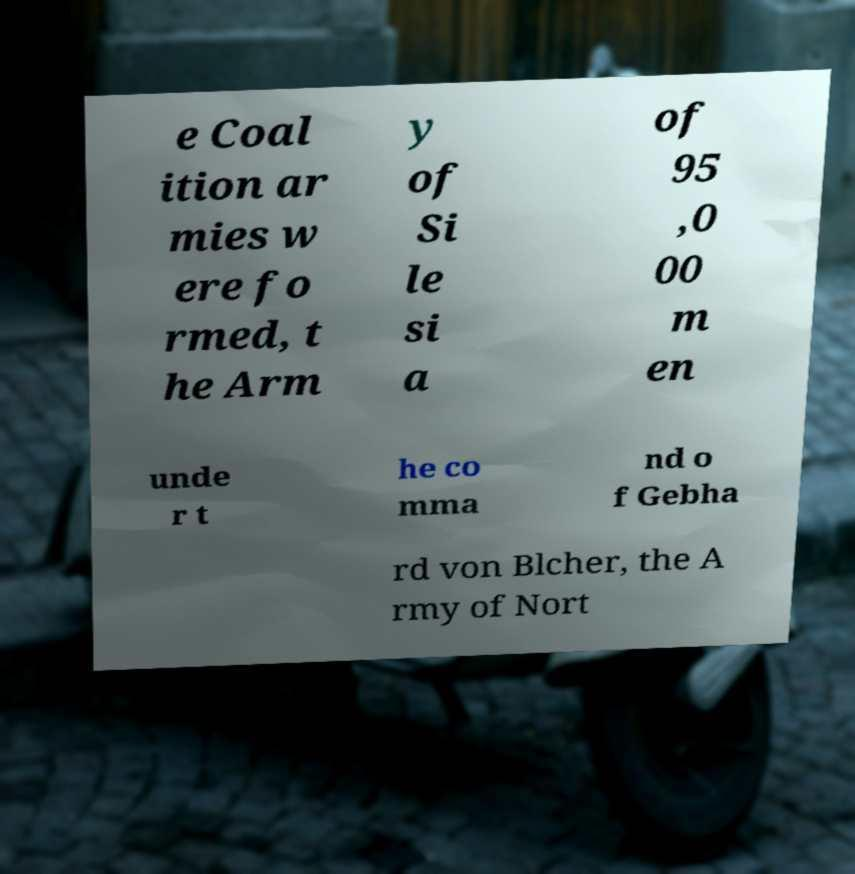There's text embedded in this image that I need extracted. Can you transcribe it verbatim? e Coal ition ar mies w ere fo rmed, t he Arm y of Si le si a of 95 ,0 00 m en unde r t he co mma nd o f Gebha rd von Blcher, the A rmy of Nort 